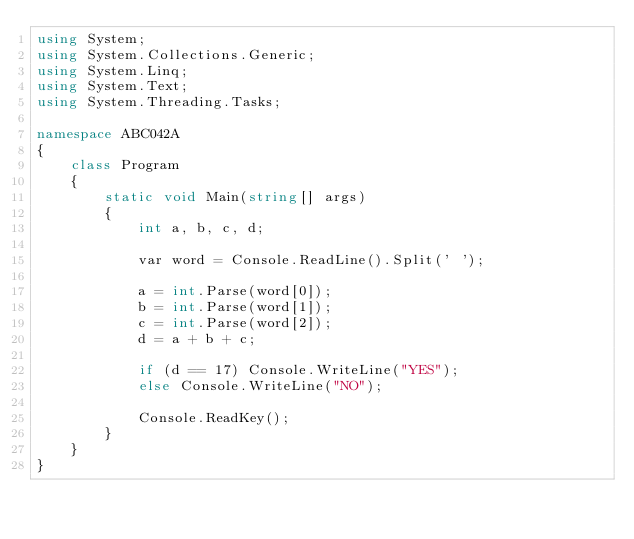Convert code to text. <code><loc_0><loc_0><loc_500><loc_500><_C#_>using System;
using System.Collections.Generic;
using System.Linq;
using System.Text;
using System.Threading.Tasks;

namespace ABC042A
{
    class Program
    {
        static void Main(string[] args)
        {
            int a, b, c, d;

            var word = Console.ReadLine().Split(' ');

            a = int.Parse(word[0]);
            b = int.Parse(word[1]);
            c = int.Parse(word[2]);
            d = a + b + c;

            if (d == 17) Console.WriteLine("YES");
            else Console.WriteLine("NO");

            Console.ReadKey();
        }
    }
}</code> 